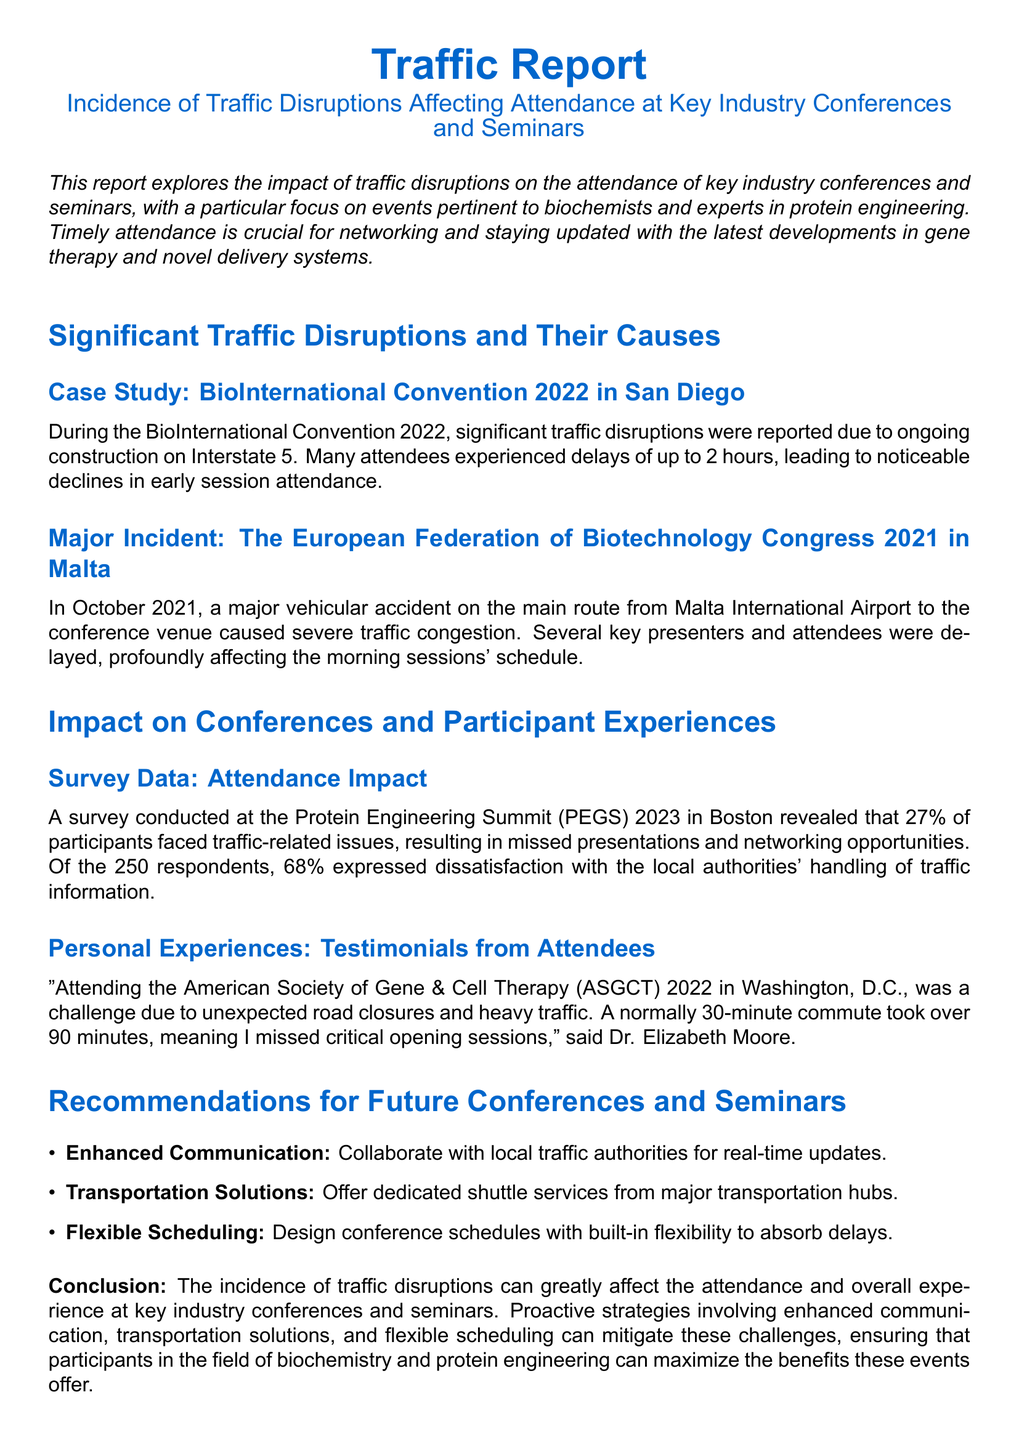What significant traffic disruption occurred during the BioInternational Convention 2022? The significant traffic disruption was due to ongoing construction on Interstate 5.
Answer: Construction on Interstate 5 What percentage of participants faced traffic-related issues at the PEGS 2023? The document states that 27% of participants faced traffic-related issues at the PEGS 2023.
Answer: 27% What was the outcome of the major vehicular accident during the European Federation of Biotechnology Congress 2021? The major vehicular accident caused severe traffic congestion and delayed key presenters and attendees.
Answer: Severe traffic congestion Who expressed dissatisfaction with local authorities' handling of traffic information at the PEGS 2023? According to the survey, 68% of the respondents expressed dissatisfaction.
Answer: 68% What transportation solution is recommended for future conferences? The recommendation includes offering dedicated shuttle services from major transportation hubs.
Answer: Dedicated shuttle services What personal challenge did Dr. Elizabeth Moore face while attending the ASGCT 2022? Dr. Elizabeth Moore faced unexpected road closures and heavy traffic on her way to the conference.
Answer: Unexpected road closures How long did the commute take for Dr. Elizabeth Moore to the ASGCT 2022? Dr. Elizabeth Moore's commute took over 90 minutes instead of the normal 30 minutes.
Answer: Over 90 minutes What type of report is this document classified as? The document is classified as a traffic report.
Answer: Traffic report 